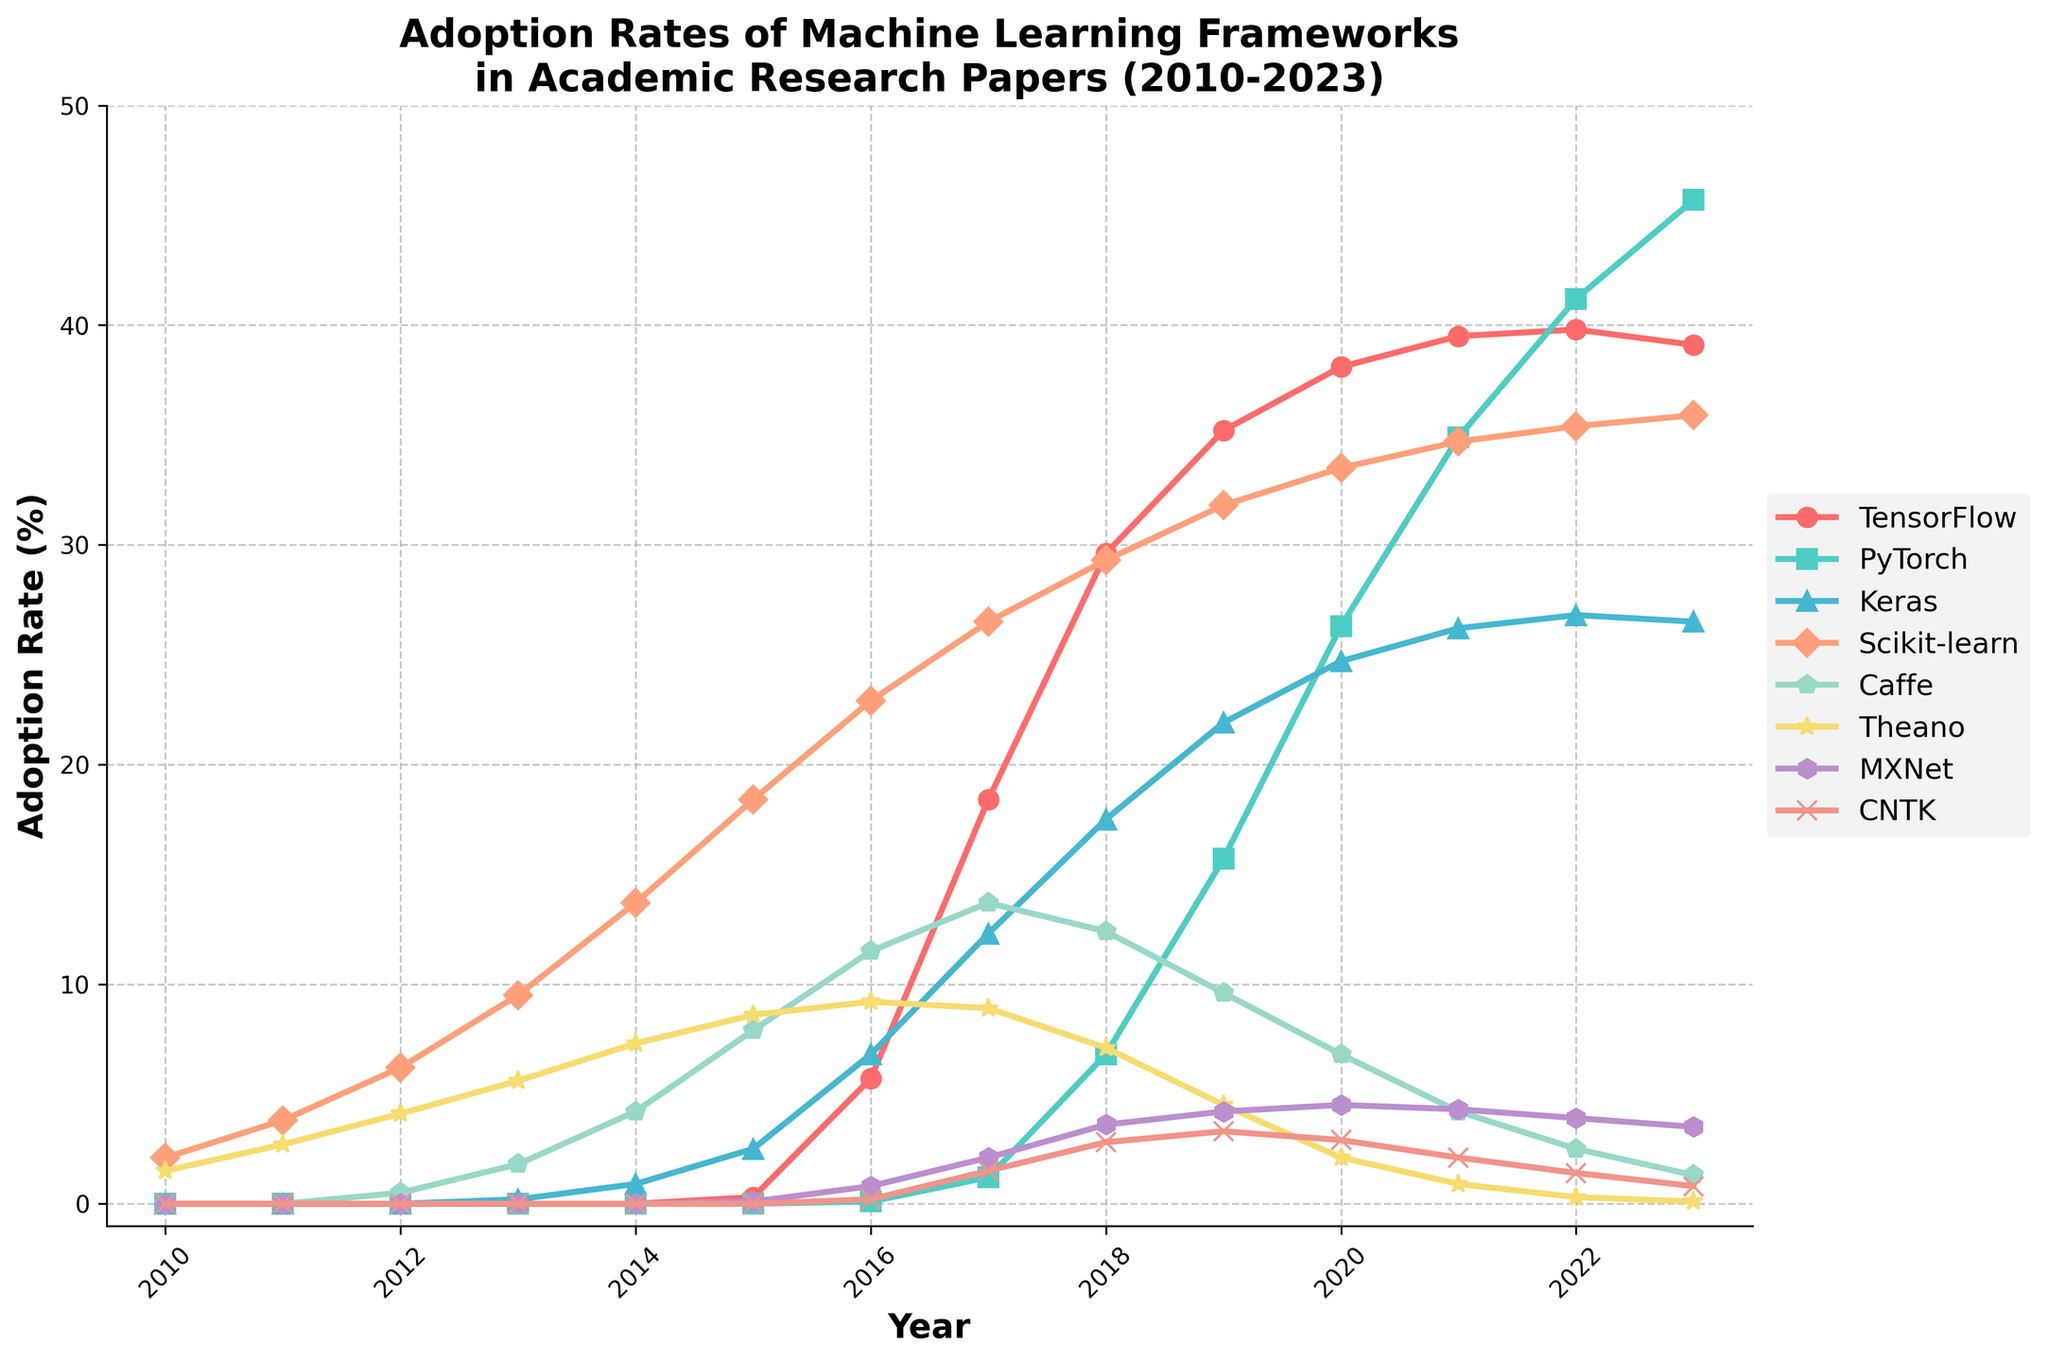When did PyTorch surpass Scikit-learn in adoption rate? Inspect the plot and find the year when PyTorch's line crosses above Scikit-learn's line. The two lines intersect between 2019 and 2020. In 2020, PyTorch adoption rate (26.3%) is more than Scikit-learn (33.5%), showing that it happens in 2020.
Answer: 2020 Which framework had the highest adoption rate in 2023? Look at the endpoints of the lines in 2023. Identify which line is at the highest position. PyTorch has the highest value in 2023 at 45.7%.
Answer: PyTorch What was the adoption rate of Keras in its first year reported? Find the first year that Keras has a non-zero value by locating the point in the plot for Keras. This occurs in 2013 with an adoption rate of 0.2%.
Answer: 0.2% Did any frameworks show a declining adoption rate trend since their peak year? Examine each line to identify if they have a peak followed by a decrease. Theano peaks in 2016 and declines afterward.
Answer: Theano Which two frameworks had consistent increases in adoption rate throughout the years 2010 to 2023? Observe the lines and look for any steady increase without significant drops. Both PyTorch and TensorFlow show consistent increases.
Answer: PyTorch and TensorFlow What is the total adoption rate of TensorFlow from 2010 to 2023? Add the annual adoption rates of TensorFlow from each year. Total is 0+0+0+0+0+0.3+5.7+18.4+29.6+35.2+38.1+39.5+39.8+39.1 = 245.7%.
Answer: 245.7% In which years did Caffe's adoption rate decrease? Look for years where the line for Caffe dips. It decreases from 2018 to 2019, from 2019 to 2020, from 2020 to 2021, from 2021 to 2022, and from 2022 to 2023.
Answer: 2019, 2020, 2021, 2022, 2023 What was the sum of the adoption rates of Theano and MXNet in 2015? Add the values of Theano and MXNet for the year 2015, which are 8.6% and 0.1% respectively. The sum is 8.7%.
Answer: 8.7% Was Scikit-learn’s adoption rate ever higher than TensorFlow in any given year after 2015? Compare the points of Scikit-learn and TensorFlow from 2016 onwards. Scikit-learn remains higher in those years compared to TensorFlow between 2016 and 2018. For 2016 (22.9 vs 5.7), 2017 (26.5 vs 18.4), and 2018 (29.3 vs 29.6) confirms it.
Answer: Yes 